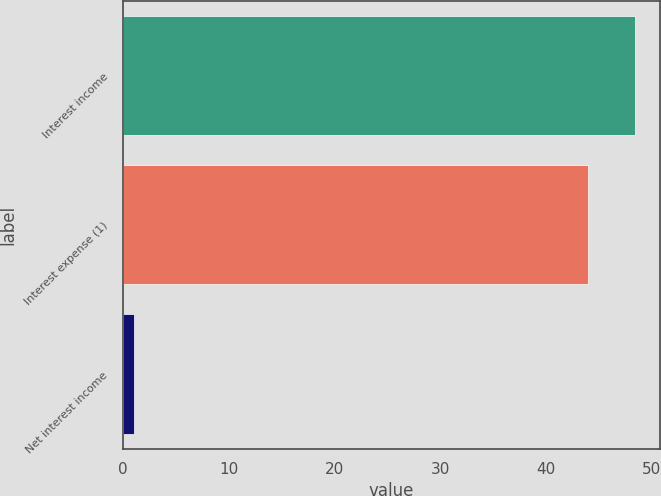<chart> <loc_0><loc_0><loc_500><loc_500><bar_chart><fcel>Interest income<fcel>Interest expense (1)<fcel>Net interest income<nl><fcel>48.4<fcel>44<fcel>1<nl></chart> 